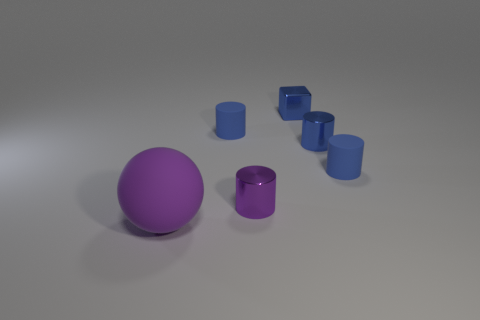The matte object that is behind the purple matte sphere and in front of the blue shiny cylinder is what color?
Offer a terse response. Blue. Are there any small cylinders that have the same color as the rubber sphere?
Keep it short and to the point. Yes. There is a small shiny thing that is on the right side of the blue block; what color is it?
Ensure brevity in your answer.  Blue. Is there a rubber sphere that is to the right of the purple thing behind the purple matte object?
Provide a short and direct response. No. There is a tiny block; does it have the same color as the rubber thing that is right of the cube?
Your answer should be very brief. Yes. Is there a tiny gray object that has the same material as the small blue cube?
Offer a very short reply. No. How many small matte cubes are there?
Ensure brevity in your answer.  0. What material is the purple object that is in front of the purple object right of the large purple matte sphere?
Provide a short and direct response. Rubber. The other cylinder that is the same material as the small purple cylinder is what color?
Provide a short and direct response. Blue. What shape is the other thing that is the same color as the big thing?
Offer a terse response. Cylinder. 